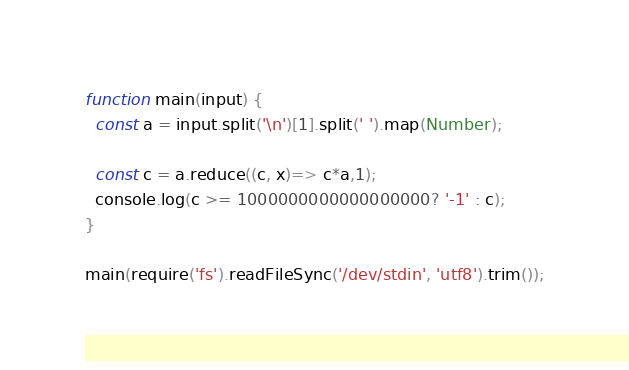Convert code to text. <code><loc_0><loc_0><loc_500><loc_500><_JavaScript_>function main(input) {
  const a = input.split('\n')[1].split(' ').map(Number);
  
  const c = a.reduce((c, x)=> c*a,1);
  console.log(c >= 1000000000000000000? '-1' : c);
}

main(require('fs').readFileSync('/dev/stdin', 'utf8').trim());</code> 